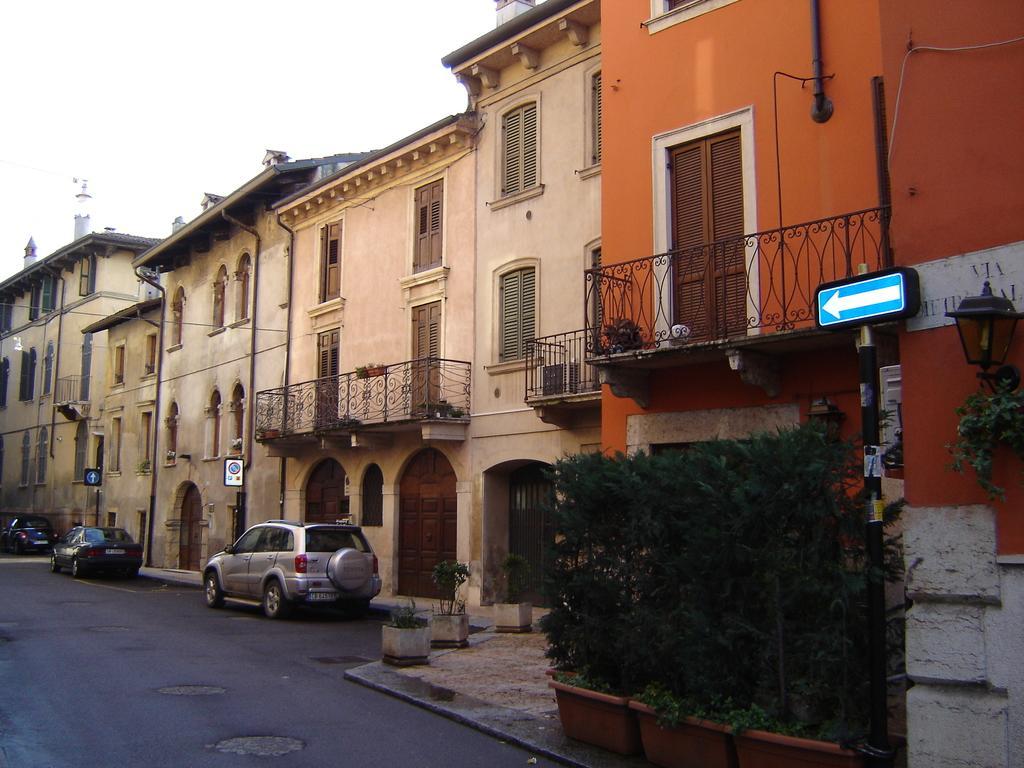Please provide a concise description of this image. On the right we can see plants, lamp, sign board and a building. In the middle of the picture there are buildings, plants and cars. On the left there are buildings, car and road. At the top there is sky. 